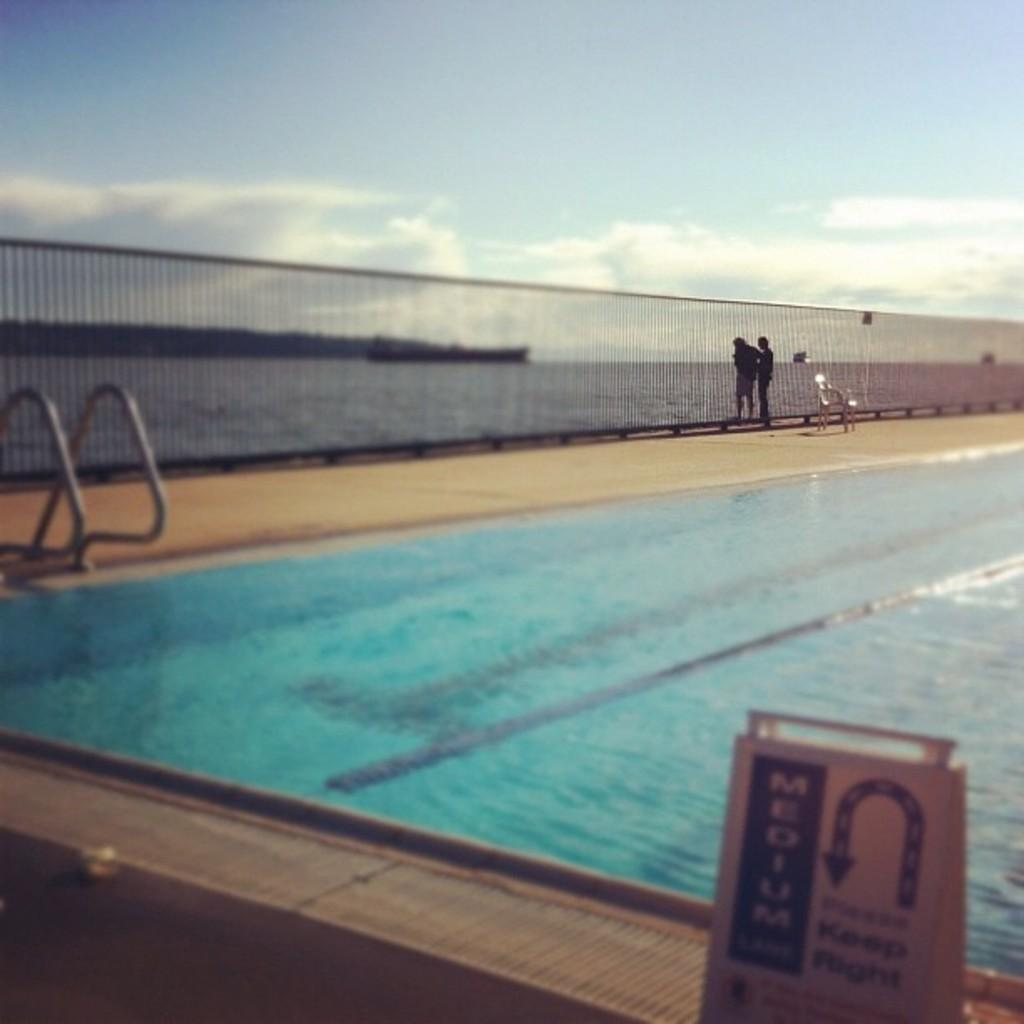What can be seen in the right corner of the image? There is a swimming pool in the right corner of the image. How many people are present in the image? There are two persons standing in the image. What is in front of the persons? There is a fence in front of the persons. What is visible in the background of the image? There is water visible in the background of the image. Can you see the moon in the image? No, the moon is not present in the image. Is there an airplane flying over the swimming pool in the image? No, there is no airplane visible in the image. 